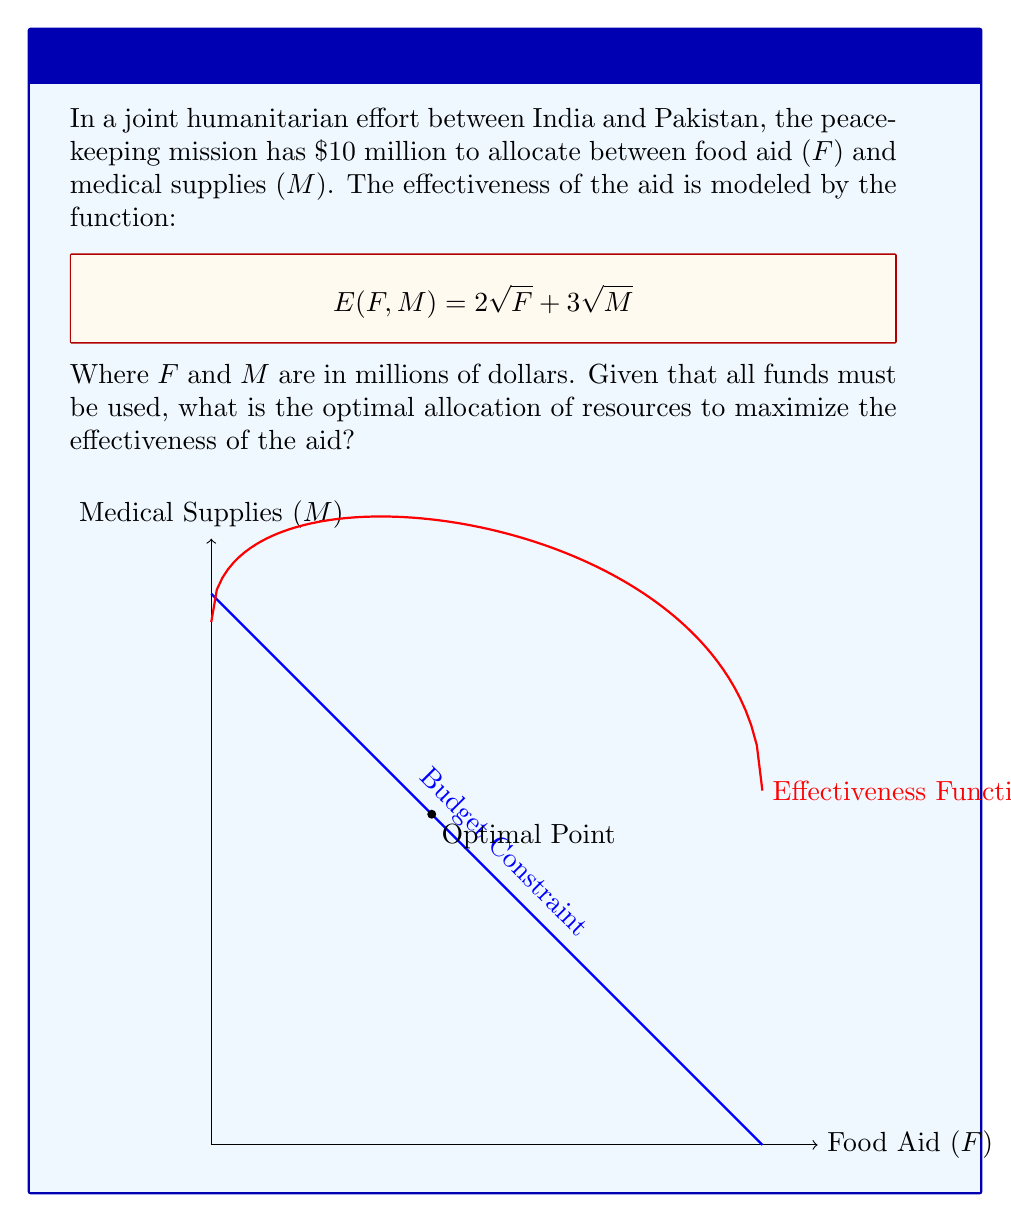Help me with this question. To solve this problem, we'll use the method of Lagrange multipliers:

1) Let's define our constraint: $F + M = 10$

2) Our objective function is: $E(F,M) = 2\sqrt{F} + 3\sqrt{M}$

3) We form the Lagrangian:
   $$L(F,M,\lambda) = 2\sqrt{F} + 3\sqrt{M} + \lambda(10 - F - M)$$

4) Now, we take partial derivatives and set them to zero:

   $$\frac{\partial L}{\partial F} = \frac{1}{\sqrt{F}} - \lambda = 0$$
   $$\frac{\partial L}{\partial M} = \frac{3}{2\sqrt{M}} - \lambda = 0$$
   $$\frac{\partial L}{\partial \lambda} = 10 - F - M = 0$$

5) From the first two equations:
   $$\frac{1}{\sqrt{F}} = \frac{3}{2\sqrt{M}}$$

6) Squaring both sides:
   $$\frac{1}{F} = \frac{9}{4M}$$

7) Cross-multiplying:
   $$4M = 9F$$

8) Substituting this into our constraint equation:
   $$F + \frac{4M}{9} = 10$$
   $$9F + 4M = 90$$

9) We now have two equations:
   $$9F + 4M = 90$$
   $$F + M = 10$$

10) Solving this system:
    $$8F = 50$$
    $$F = 6.25$$
    $$M = 3.75$$

Therefore, the optimal allocation is $6.25 million for food aid and $3.75 million for medical supplies.
Answer: $F = 6.25$ million, $M = 3.75$ million 